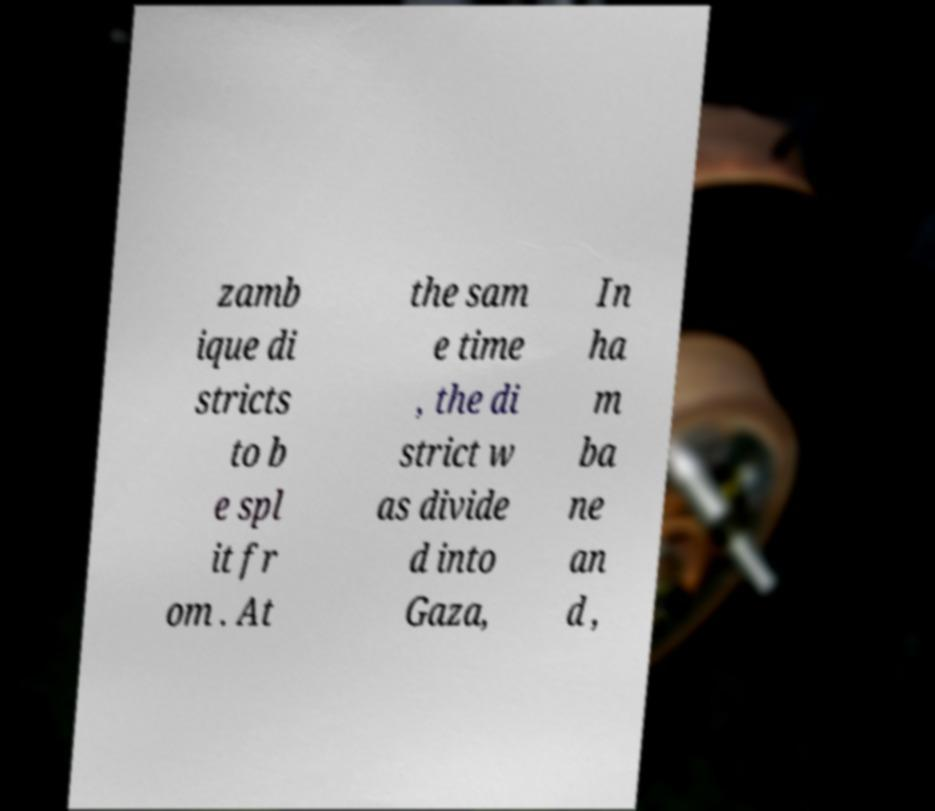I need the written content from this picture converted into text. Can you do that? zamb ique di stricts to b e spl it fr om . At the sam e time , the di strict w as divide d into Gaza, In ha m ba ne an d , 